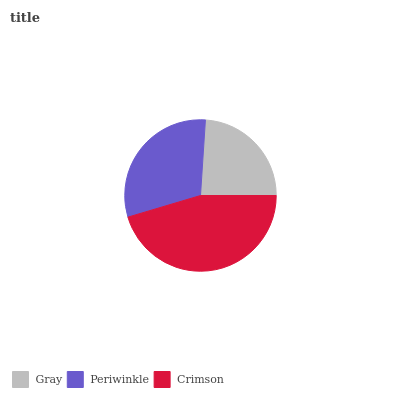Is Gray the minimum?
Answer yes or no. Yes. Is Crimson the maximum?
Answer yes or no. Yes. Is Periwinkle the minimum?
Answer yes or no. No. Is Periwinkle the maximum?
Answer yes or no. No. Is Periwinkle greater than Gray?
Answer yes or no. Yes. Is Gray less than Periwinkle?
Answer yes or no. Yes. Is Gray greater than Periwinkle?
Answer yes or no. No. Is Periwinkle less than Gray?
Answer yes or no. No. Is Periwinkle the high median?
Answer yes or no. Yes. Is Periwinkle the low median?
Answer yes or no. Yes. Is Gray the high median?
Answer yes or no. No. Is Crimson the low median?
Answer yes or no. No. 